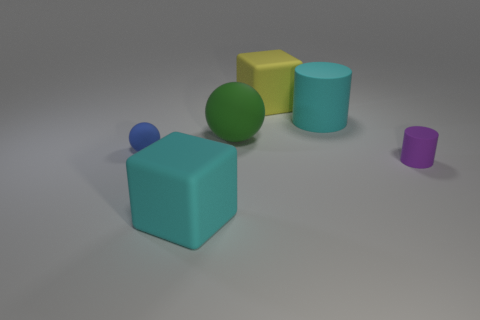The other rubber thing that is the same shape as the yellow matte object is what size?
Ensure brevity in your answer.  Large. What size is the cube that is the same color as the big matte cylinder?
Your answer should be very brief. Large. Are the tiny blue sphere and the large ball made of the same material?
Your response must be concise. Yes. The rubber sphere that is the same size as the cyan cylinder is what color?
Make the answer very short. Green. What number of other big matte objects are the same shape as the blue object?
Your answer should be compact. 1. What number of blocks are either things or blue rubber things?
Ensure brevity in your answer.  2. There is a rubber object in front of the tiny purple cylinder; is its shape the same as the big yellow thing on the right side of the big green thing?
Give a very brief answer. Yes. What material is the yellow object?
Offer a very short reply. Rubber. How many rubber cylinders are the same size as the blue rubber thing?
Offer a very short reply. 1. How many objects are either cylinders that are to the left of the small purple rubber thing or things behind the blue matte thing?
Offer a very short reply. 3. 